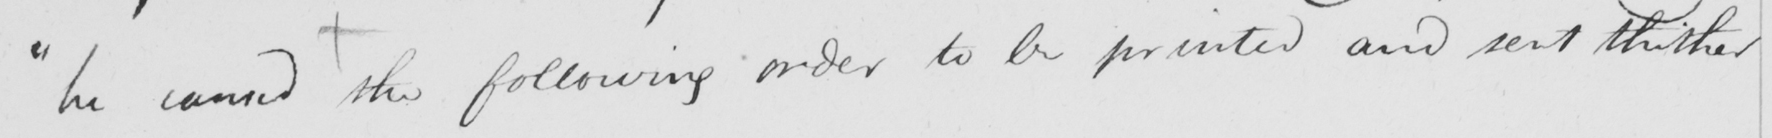Please provide the text content of this handwritten line. " he caused the following order to be printed and sent thither 